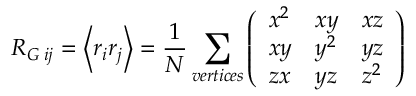<formula> <loc_0><loc_0><loc_500><loc_500>R _ { G \, i j } = \left \langle r _ { i } r _ { j } \right \rangle = \frac { 1 } { N } \sum _ { v e r t i c e s } \left ( \begin{array} { l l l } { x ^ { 2 } } & { x y } & { x z } \\ { x y } & { y ^ { 2 } } & { y z } \\ { z x } & { y z } & { z ^ { 2 } } \end{array} \right )</formula> 